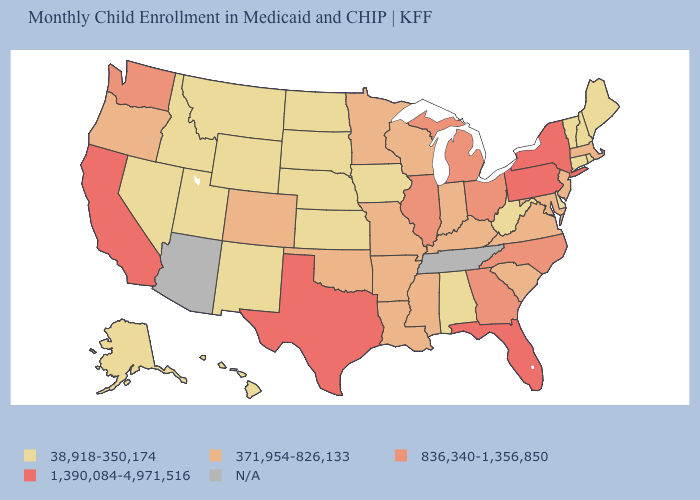Which states hav the highest value in the Northeast?
Be succinct. New York, Pennsylvania. What is the lowest value in states that border Connecticut?
Quick response, please. 38,918-350,174. What is the value of Virginia?
Be succinct. 371,954-826,133. What is the value of Connecticut?
Short answer required. 38,918-350,174. Is the legend a continuous bar?
Be succinct. No. Among the states that border Kansas , which have the lowest value?
Concise answer only. Nebraska. Name the states that have a value in the range 836,340-1,356,850?
Quick response, please. Georgia, Illinois, Michigan, North Carolina, Ohio, Washington. Name the states that have a value in the range 38,918-350,174?
Concise answer only. Alabama, Alaska, Connecticut, Delaware, Hawaii, Idaho, Iowa, Kansas, Maine, Montana, Nebraska, Nevada, New Hampshire, New Mexico, North Dakota, Rhode Island, South Dakota, Utah, Vermont, West Virginia, Wyoming. Does Texas have the lowest value in the USA?
Write a very short answer. No. What is the value of Connecticut?
Answer briefly. 38,918-350,174. Does West Virginia have the lowest value in the USA?
Quick response, please. Yes. Name the states that have a value in the range 371,954-826,133?
Keep it brief. Arkansas, Colorado, Indiana, Kentucky, Louisiana, Maryland, Massachusetts, Minnesota, Mississippi, Missouri, New Jersey, Oklahoma, Oregon, South Carolina, Virginia, Wisconsin. Among the states that border Indiana , which have the highest value?
Answer briefly. Illinois, Michigan, Ohio. What is the value of North Carolina?
Concise answer only. 836,340-1,356,850. Among the states that border Louisiana , does Texas have the highest value?
Write a very short answer. Yes. 